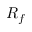Convert formula to latex. <formula><loc_0><loc_0><loc_500><loc_500>R _ { f }</formula> 